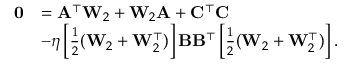<formula> <loc_0><loc_0><loc_500><loc_500>\begin{array} { r l } { 0 } & { = A ^ { \top } W _ { 2 } + W _ { 2 } A + C ^ { \top } C } \\ & { - \eta \left [ \frac { 1 } { 2 } ( W _ { 2 } + W _ { 2 } ^ { \top } ) \right ] B B ^ { \top } \left [ \frac { 1 } { 2 } ( W _ { 2 } + W _ { 2 } ^ { \top } ) \right ] . } \end{array}</formula> 